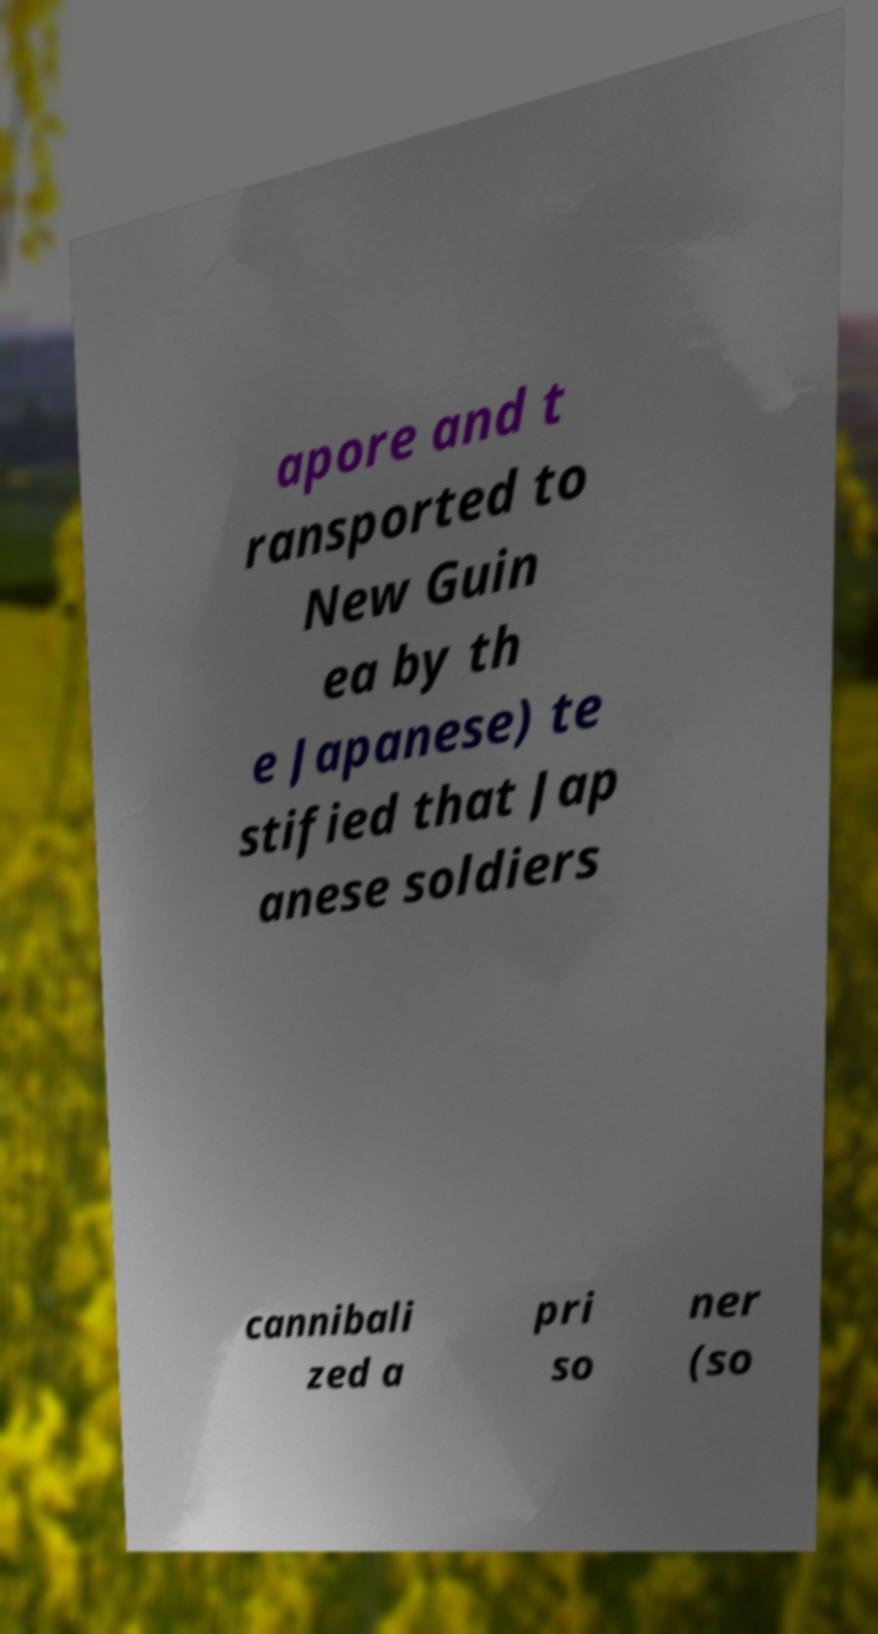I need the written content from this picture converted into text. Can you do that? apore and t ransported to New Guin ea by th e Japanese) te stified that Jap anese soldiers cannibali zed a pri so ner (so 